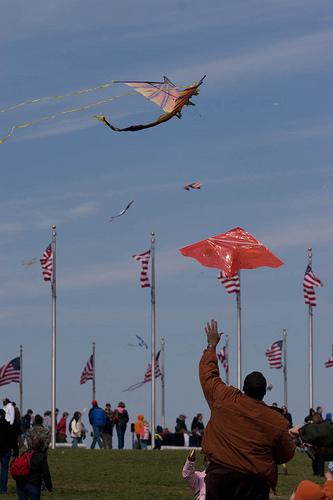Describe the general atmosphere and main activity taking place in the image. The atmosphere is lively and joyful as a crowd of people is enjoying flying various kites of different colors and shapes at a park with green grass and blue sky. Using a single sentence, describe the main event happening in the image. Numerous people are gathered at a park with well-manicured green lawn, watching and flying vibrant kites in the air under a cloudy blue sky. Highlight the most significant landmarks and features in the image. The image features a beautiful park with lush green grass as well as distinctive kites, such as dragon and rainbow kites, being flown in the sky by cheerful park visitors. Describe the various kites and flags visible in the image. The image showcases a variety of kites, including dragon and rainbow kites, along with numerous American flags waving from tall silver poles scattered across the park. Provide a brief description of the scene in the image. The image displays a bright park scene with many people flying kites, including dragon and rainbow kites, in a blue sky with clouds and a green lawn below. Mention the predominant colors in the image and which objects they relate to. The image has a blue-colored sky with some white clouds, green-colored grass, and a red kite is in the air along with other colorful kites. Describe the outdoor setting presented in the image. The setting is a lively park with a well-manicured green lawn, under a sky with blue hues and white clouds, occupied by people flying colorful kites. Identify and describe the most eye-catching object in the image. A large dragon-shaped kite is in the air, attracting attention with its unique design and colorful appearance among other kites. Mention any interesting clothing or accessories observed on people within the image. A person is wearing a brown jacket, a child has a red backpack, another person has an orange hooded winter jacket, and someone else wears a pink jacket. Identify any significant features in the sky and on the ground. The sky features blue color and cloudy, containing various kites, while the ground displays a vibrant green park with people enjoying kite flying and waving American flags. 